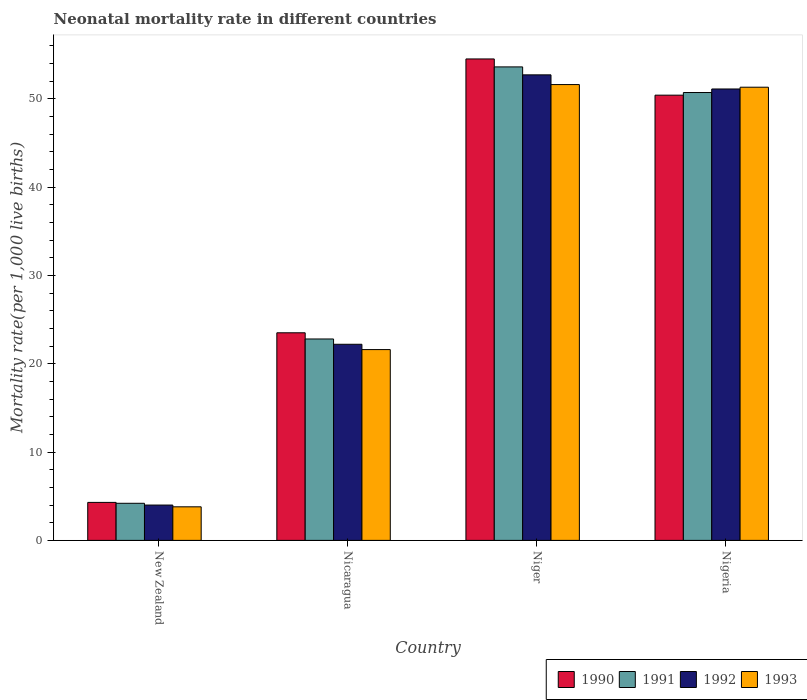How many groups of bars are there?
Make the answer very short. 4. How many bars are there on the 3rd tick from the right?
Offer a terse response. 4. What is the label of the 2nd group of bars from the left?
Provide a succinct answer. Nicaragua. What is the neonatal mortality rate in 1991 in New Zealand?
Offer a very short reply. 4.2. Across all countries, what is the maximum neonatal mortality rate in 1993?
Your answer should be compact. 51.6. Across all countries, what is the minimum neonatal mortality rate in 1993?
Your answer should be very brief. 3.8. In which country was the neonatal mortality rate in 1992 maximum?
Offer a very short reply. Niger. In which country was the neonatal mortality rate in 1990 minimum?
Give a very brief answer. New Zealand. What is the total neonatal mortality rate in 1992 in the graph?
Offer a very short reply. 130. What is the difference between the neonatal mortality rate in 1990 in Nicaragua and that in Niger?
Provide a short and direct response. -31. What is the difference between the neonatal mortality rate in 1990 in Niger and the neonatal mortality rate in 1992 in Nigeria?
Give a very brief answer. 3.4. What is the average neonatal mortality rate in 1991 per country?
Provide a short and direct response. 32.83. What is the difference between the neonatal mortality rate of/in 1992 and neonatal mortality rate of/in 1991 in New Zealand?
Give a very brief answer. -0.2. What is the ratio of the neonatal mortality rate in 1990 in New Zealand to that in Nicaragua?
Offer a terse response. 0.18. Is the neonatal mortality rate in 1991 in New Zealand less than that in Nigeria?
Make the answer very short. Yes. Is the difference between the neonatal mortality rate in 1992 in Nicaragua and Nigeria greater than the difference between the neonatal mortality rate in 1991 in Nicaragua and Nigeria?
Your answer should be very brief. No. What is the difference between the highest and the second highest neonatal mortality rate in 1992?
Ensure brevity in your answer.  -1.6. What is the difference between the highest and the lowest neonatal mortality rate in 1990?
Your response must be concise. 50.2. In how many countries, is the neonatal mortality rate in 1992 greater than the average neonatal mortality rate in 1992 taken over all countries?
Make the answer very short. 2. Is it the case that in every country, the sum of the neonatal mortality rate in 1991 and neonatal mortality rate in 1992 is greater than the sum of neonatal mortality rate in 1990 and neonatal mortality rate in 1993?
Give a very brief answer. No. What does the 4th bar from the right in Niger represents?
Give a very brief answer. 1990. Is it the case that in every country, the sum of the neonatal mortality rate in 1990 and neonatal mortality rate in 1991 is greater than the neonatal mortality rate in 1993?
Provide a short and direct response. Yes. How many bars are there?
Provide a succinct answer. 16. How many countries are there in the graph?
Offer a very short reply. 4. Are the values on the major ticks of Y-axis written in scientific E-notation?
Provide a short and direct response. No. Does the graph contain any zero values?
Keep it short and to the point. No. Does the graph contain grids?
Your answer should be compact. No. Where does the legend appear in the graph?
Keep it short and to the point. Bottom right. How are the legend labels stacked?
Provide a succinct answer. Horizontal. What is the title of the graph?
Offer a very short reply. Neonatal mortality rate in different countries. Does "2010" appear as one of the legend labels in the graph?
Your answer should be compact. No. What is the label or title of the X-axis?
Make the answer very short. Country. What is the label or title of the Y-axis?
Offer a very short reply. Mortality rate(per 1,0 live births). What is the Mortality rate(per 1,000 live births) of 1990 in New Zealand?
Give a very brief answer. 4.3. What is the Mortality rate(per 1,000 live births) in 1992 in New Zealand?
Your answer should be very brief. 4. What is the Mortality rate(per 1,000 live births) in 1991 in Nicaragua?
Give a very brief answer. 22.8. What is the Mortality rate(per 1,000 live births) of 1992 in Nicaragua?
Ensure brevity in your answer.  22.2. What is the Mortality rate(per 1,000 live births) of 1993 in Nicaragua?
Keep it short and to the point. 21.6. What is the Mortality rate(per 1,000 live births) of 1990 in Niger?
Offer a terse response. 54.5. What is the Mortality rate(per 1,000 live births) in 1991 in Niger?
Your answer should be very brief. 53.6. What is the Mortality rate(per 1,000 live births) in 1992 in Niger?
Give a very brief answer. 52.7. What is the Mortality rate(per 1,000 live births) of 1993 in Niger?
Your answer should be very brief. 51.6. What is the Mortality rate(per 1,000 live births) of 1990 in Nigeria?
Your response must be concise. 50.4. What is the Mortality rate(per 1,000 live births) of 1991 in Nigeria?
Provide a short and direct response. 50.7. What is the Mortality rate(per 1,000 live births) in 1992 in Nigeria?
Your response must be concise. 51.1. What is the Mortality rate(per 1,000 live births) in 1993 in Nigeria?
Make the answer very short. 51.3. Across all countries, what is the maximum Mortality rate(per 1,000 live births) of 1990?
Provide a succinct answer. 54.5. Across all countries, what is the maximum Mortality rate(per 1,000 live births) of 1991?
Your answer should be compact. 53.6. Across all countries, what is the maximum Mortality rate(per 1,000 live births) in 1992?
Offer a very short reply. 52.7. Across all countries, what is the maximum Mortality rate(per 1,000 live births) in 1993?
Ensure brevity in your answer.  51.6. Across all countries, what is the minimum Mortality rate(per 1,000 live births) of 1991?
Give a very brief answer. 4.2. Across all countries, what is the minimum Mortality rate(per 1,000 live births) of 1992?
Make the answer very short. 4. What is the total Mortality rate(per 1,000 live births) of 1990 in the graph?
Your answer should be compact. 132.7. What is the total Mortality rate(per 1,000 live births) in 1991 in the graph?
Your response must be concise. 131.3. What is the total Mortality rate(per 1,000 live births) of 1992 in the graph?
Keep it short and to the point. 130. What is the total Mortality rate(per 1,000 live births) in 1993 in the graph?
Ensure brevity in your answer.  128.3. What is the difference between the Mortality rate(per 1,000 live births) in 1990 in New Zealand and that in Nicaragua?
Keep it short and to the point. -19.2. What is the difference between the Mortality rate(per 1,000 live births) of 1991 in New Zealand and that in Nicaragua?
Your answer should be compact. -18.6. What is the difference between the Mortality rate(per 1,000 live births) of 1992 in New Zealand and that in Nicaragua?
Your answer should be compact. -18.2. What is the difference between the Mortality rate(per 1,000 live births) in 1993 in New Zealand and that in Nicaragua?
Give a very brief answer. -17.8. What is the difference between the Mortality rate(per 1,000 live births) of 1990 in New Zealand and that in Niger?
Ensure brevity in your answer.  -50.2. What is the difference between the Mortality rate(per 1,000 live births) in 1991 in New Zealand and that in Niger?
Offer a terse response. -49.4. What is the difference between the Mortality rate(per 1,000 live births) of 1992 in New Zealand and that in Niger?
Ensure brevity in your answer.  -48.7. What is the difference between the Mortality rate(per 1,000 live births) in 1993 in New Zealand and that in Niger?
Your answer should be very brief. -47.8. What is the difference between the Mortality rate(per 1,000 live births) of 1990 in New Zealand and that in Nigeria?
Keep it short and to the point. -46.1. What is the difference between the Mortality rate(per 1,000 live births) of 1991 in New Zealand and that in Nigeria?
Your answer should be compact. -46.5. What is the difference between the Mortality rate(per 1,000 live births) of 1992 in New Zealand and that in Nigeria?
Ensure brevity in your answer.  -47.1. What is the difference between the Mortality rate(per 1,000 live births) in 1993 in New Zealand and that in Nigeria?
Your answer should be very brief. -47.5. What is the difference between the Mortality rate(per 1,000 live births) of 1990 in Nicaragua and that in Niger?
Give a very brief answer. -31. What is the difference between the Mortality rate(per 1,000 live births) in 1991 in Nicaragua and that in Niger?
Provide a succinct answer. -30.8. What is the difference between the Mortality rate(per 1,000 live births) in 1992 in Nicaragua and that in Niger?
Provide a succinct answer. -30.5. What is the difference between the Mortality rate(per 1,000 live births) in 1993 in Nicaragua and that in Niger?
Make the answer very short. -30. What is the difference between the Mortality rate(per 1,000 live births) in 1990 in Nicaragua and that in Nigeria?
Keep it short and to the point. -26.9. What is the difference between the Mortality rate(per 1,000 live births) in 1991 in Nicaragua and that in Nigeria?
Give a very brief answer. -27.9. What is the difference between the Mortality rate(per 1,000 live births) in 1992 in Nicaragua and that in Nigeria?
Your answer should be compact. -28.9. What is the difference between the Mortality rate(per 1,000 live births) of 1993 in Nicaragua and that in Nigeria?
Offer a terse response. -29.7. What is the difference between the Mortality rate(per 1,000 live births) of 1992 in Niger and that in Nigeria?
Give a very brief answer. 1.6. What is the difference between the Mortality rate(per 1,000 live births) of 1990 in New Zealand and the Mortality rate(per 1,000 live births) of 1991 in Nicaragua?
Your answer should be compact. -18.5. What is the difference between the Mortality rate(per 1,000 live births) in 1990 in New Zealand and the Mortality rate(per 1,000 live births) in 1992 in Nicaragua?
Ensure brevity in your answer.  -17.9. What is the difference between the Mortality rate(per 1,000 live births) of 1990 in New Zealand and the Mortality rate(per 1,000 live births) of 1993 in Nicaragua?
Keep it short and to the point. -17.3. What is the difference between the Mortality rate(per 1,000 live births) in 1991 in New Zealand and the Mortality rate(per 1,000 live births) in 1992 in Nicaragua?
Provide a short and direct response. -18. What is the difference between the Mortality rate(per 1,000 live births) in 1991 in New Zealand and the Mortality rate(per 1,000 live births) in 1993 in Nicaragua?
Ensure brevity in your answer.  -17.4. What is the difference between the Mortality rate(per 1,000 live births) in 1992 in New Zealand and the Mortality rate(per 1,000 live births) in 1993 in Nicaragua?
Give a very brief answer. -17.6. What is the difference between the Mortality rate(per 1,000 live births) in 1990 in New Zealand and the Mortality rate(per 1,000 live births) in 1991 in Niger?
Provide a succinct answer. -49.3. What is the difference between the Mortality rate(per 1,000 live births) of 1990 in New Zealand and the Mortality rate(per 1,000 live births) of 1992 in Niger?
Your response must be concise. -48.4. What is the difference between the Mortality rate(per 1,000 live births) in 1990 in New Zealand and the Mortality rate(per 1,000 live births) in 1993 in Niger?
Your answer should be very brief. -47.3. What is the difference between the Mortality rate(per 1,000 live births) in 1991 in New Zealand and the Mortality rate(per 1,000 live births) in 1992 in Niger?
Keep it short and to the point. -48.5. What is the difference between the Mortality rate(per 1,000 live births) in 1991 in New Zealand and the Mortality rate(per 1,000 live births) in 1993 in Niger?
Offer a terse response. -47.4. What is the difference between the Mortality rate(per 1,000 live births) of 1992 in New Zealand and the Mortality rate(per 1,000 live births) of 1993 in Niger?
Offer a terse response. -47.6. What is the difference between the Mortality rate(per 1,000 live births) of 1990 in New Zealand and the Mortality rate(per 1,000 live births) of 1991 in Nigeria?
Keep it short and to the point. -46.4. What is the difference between the Mortality rate(per 1,000 live births) in 1990 in New Zealand and the Mortality rate(per 1,000 live births) in 1992 in Nigeria?
Your response must be concise. -46.8. What is the difference between the Mortality rate(per 1,000 live births) of 1990 in New Zealand and the Mortality rate(per 1,000 live births) of 1993 in Nigeria?
Keep it short and to the point. -47. What is the difference between the Mortality rate(per 1,000 live births) of 1991 in New Zealand and the Mortality rate(per 1,000 live births) of 1992 in Nigeria?
Your response must be concise. -46.9. What is the difference between the Mortality rate(per 1,000 live births) of 1991 in New Zealand and the Mortality rate(per 1,000 live births) of 1993 in Nigeria?
Offer a terse response. -47.1. What is the difference between the Mortality rate(per 1,000 live births) of 1992 in New Zealand and the Mortality rate(per 1,000 live births) of 1993 in Nigeria?
Ensure brevity in your answer.  -47.3. What is the difference between the Mortality rate(per 1,000 live births) of 1990 in Nicaragua and the Mortality rate(per 1,000 live births) of 1991 in Niger?
Your answer should be compact. -30.1. What is the difference between the Mortality rate(per 1,000 live births) of 1990 in Nicaragua and the Mortality rate(per 1,000 live births) of 1992 in Niger?
Offer a very short reply. -29.2. What is the difference between the Mortality rate(per 1,000 live births) in 1990 in Nicaragua and the Mortality rate(per 1,000 live births) in 1993 in Niger?
Provide a short and direct response. -28.1. What is the difference between the Mortality rate(per 1,000 live births) of 1991 in Nicaragua and the Mortality rate(per 1,000 live births) of 1992 in Niger?
Keep it short and to the point. -29.9. What is the difference between the Mortality rate(per 1,000 live births) of 1991 in Nicaragua and the Mortality rate(per 1,000 live births) of 1993 in Niger?
Your answer should be compact. -28.8. What is the difference between the Mortality rate(per 1,000 live births) of 1992 in Nicaragua and the Mortality rate(per 1,000 live births) of 1993 in Niger?
Your response must be concise. -29.4. What is the difference between the Mortality rate(per 1,000 live births) in 1990 in Nicaragua and the Mortality rate(per 1,000 live births) in 1991 in Nigeria?
Ensure brevity in your answer.  -27.2. What is the difference between the Mortality rate(per 1,000 live births) in 1990 in Nicaragua and the Mortality rate(per 1,000 live births) in 1992 in Nigeria?
Provide a succinct answer. -27.6. What is the difference between the Mortality rate(per 1,000 live births) of 1990 in Nicaragua and the Mortality rate(per 1,000 live births) of 1993 in Nigeria?
Your answer should be very brief. -27.8. What is the difference between the Mortality rate(per 1,000 live births) of 1991 in Nicaragua and the Mortality rate(per 1,000 live births) of 1992 in Nigeria?
Provide a succinct answer. -28.3. What is the difference between the Mortality rate(per 1,000 live births) in 1991 in Nicaragua and the Mortality rate(per 1,000 live births) in 1993 in Nigeria?
Your response must be concise. -28.5. What is the difference between the Mortality rate(per 1,000 live births) of 1992 in Nicaragua and the Mortality rate(per 1,000 live births) of 1993 in Nigeria?
Your answer should be compact. -29.1. What is the difference between the Mortality rate(per 1,000 live births) in 1990 in Niger and the Mortality rate(per 1,000 live births) in 1991 in Nigeria?
Provide a succinct answer. 3.8. What is the difference between the Mortality rate(per 1,000 live births) in 1990 in Niger and the Mortality rate(per 1,000 live births) in 1992 in Nigeria?
Your answer should be compact. 3.4. What is the difference between the Mortality rate(per 1,000 live births) in 1991 in Niger and the Mortality rate(per 1,000 live births) in 1992 in Nigeria?
Make the answer very short. 2.5. What is the difference between the Mortality rate(per 1,000 live births) of 1991 in Niger and the Mortality rate(per 1,000 live births) of 1993 in Nigeria?
Offer a very short reply. 2.3. What is the average Mortality rate(per 1,000 live births) of 1990 per country?
Keep it short and to the point. 33.17. What is the average Mortality rate(per 1,000 live births) in 1991 per country?
Offer a very short reply. 32.83. What is the average Mortality rate(per 1,000 live births) of 1992 per country?
Your answer should be very brief. 32.5. What is the average Mortality rate(per 1,000 live births) in 1993 per country?
Your response must be concise. 32.08. What is the difference between the Mortality rate(per 1,000 live births) in 1990 and Mortality rate(per 1,000 live births) in 1991 in New Zealand?
Provide a short and direct response. 0.1. What is the difference between the Mortality rate(per 1,000 live births) of 1990 and Mortality rate(per 1,000 live births) of 1993 in New Zealand?
Your answer should be compact. 0.5. What is the difference between the Mortality rate(per 1,000 live births) of 1991 and Mortality rate(per 1,000 live births) of 1992 in New Zealand?
Give a very brief answer. 0.2. What is the difference between the Mortality rate(per 1,000 live births) in 1991 and Mortality rate(per 1,000 live births) in 1993 in New Zealand?
Provide a succinct answer. 0.4. What is the difference between the Mortality rate(per 1,000 live births) of 1992 and Mortality rate(per 1,000 live births) of 1993 in New Zealand?
Make the answer very short. 0.2. What is the difference between the Mortality rate(per 1,000 live births) of 1991 and Mortality rate(per 1,000 live births) of 1992 in Nicaragua?
Your answer should be very brief. 0.6. What is the difference between the Mortality rate(per 1,000 live births) in 1991 and Mortality rate(per 1,000 live births) in 1993 in Nicaragua?
Keep it short and to the point. 1.2. What is the difference between the Mortality rate(per 1,000 live births) of 1990 and Mortality rate(per 1,000 live births) of 1992 in Niger?
Give a very brief answer. 1.8. What is the difference between the Mortality rate(per 1,000 live births) in 1990 and Mortality rate(per 1,000 live births) in 1993 in Niger?
Ensure brevity in your answer.  2.9. What is the difference between the Mortality rate(per 1,000 live births) of 1991 and Mortality rate(per 1,000 live births) of 1992 in Niger?
Make the answer very short. 0.9. What is the difference between the Mortality rate(per 1,000 live births) in 1991 and Mortality rate(per 1,000 live births) in 1993 in Niger?
Offer a very short reply. 2. What is the difference between the Mortality rate(per 1,000 live births) of 1990 and Mortality rate(per 1,000 live births) of 1993 in Nigeria?
Provide a succinct answer. -0.9. What is the ratio of the Mortality rate(per 1,000 live births) of 1990 in New Zealand to that in Nicaragua?
Your response must be concise. 0.18. What is the ratio of the Mortality rate(per 1,000 live births) in 1991 in New Zealand to that in Nicaragua?
Keep it short and to the point. 0.18. What is the ratio of the Mortality rate(per 1,000 live births) of 1992 in New Zealand to that in Nicaragua?
Your answer should be very brief. 0.18. What is the ratio of the Mortality rate(per 1,000 live births) in 1993 in New Zealand to that in Nicaragua?
Give a very brief answer. 0.18. What is the ratio of the Mortality rate(per 1,000 live births) in 1990 in New Zealand to that in Niger?
Make the answer very short. 0.08. What is the ratio of the Mortality rate(per 1,000 live births) in 1991 in New Zealand to that in Niger?
Offer a very short reply. 0.08. What is the ratio of the Mortality rate(per 1,000 live births) of 1992 in New Zealand to that in Niger?
Your answer should be compact. 0.08. What is the ratio of the Mortality rate(per 1,000 live births) of 1993 in New Zealand to that in Niger?
Give a very brief answer. 0.07. What is the ratio of the Mortality rate(per 1,000 live births) in 1990 in New Zealand to that in Nigeria?
Ensure brevity in your answer.  0.09. What is the ratio of the Mortality rate(per 1,000 live births) in 1991 in New Zealand to that in Nigeria?
Your answer should be very brief. 0.08. What is the ratio of the Mortality rate(per 1,000 live births) in 1992 in New Zealand to that in Nigeria?
Provide a succinct answer. 0.08. What is the ratio of the Mortality rate(per 1,000 live births) of 1993 in New Zealand to that in Nigeria?
Offer a very short reply. 0.07. What is the ratio of the Mortality rate(per 1,000 live births) in 1990 in Nicaragua to that in Niger?
Your response must be concise. 0.43. What is the ratio of the Mortality rate(per 1,000 live births) in 1991 in Nicaragua to that in Niger?
Offer a terse response. 0.43. What is the ratio of the Mortality rate(per 1,000 live births) of 1992 in Nicaragua to that in Niger?
Your response must be concise. 0.42. What is the ratio of the Mortality rate(per 1,000 live births) of 1993 in Nicaragua to that in Niger?
Provide a succinct answer. 0.42. What is the ratio of the Mortality rate(per 1,000 live births) in 1990 in Nicaragua to that in Nigeria?
Provide a succinct answer. 0.47. What is the ratio of the Mortality rate(per 1,000 live births) in 1991 in Nicaragua to that in Nigeria?
Your answer should be very brief. 0.45. What is the ratio of the Mortality rate(per 1,000 live births) of 1992 in Nicaragua to that in Nigeria?
Provide a short and direct response. 0.43. What is the ratio of the Mortality rate(per 1,000 live births) in 1993 in Nicaragua to that in Nigeria?
Your answer should be compact. 0.42. What is the ratio of the Mortality rate(per 1,000 live births) in 1990 in Niger to that in Nigeria?
Offer a very short reply. 1.08. What is the ratio of the Mortality rate(per 1,000 live births) in 1991 in Niger to that in Nigeria?
Offer a terse response. 1.06. What is the ratio of the Mortality rate(per 1,000 live births) in 1992 in Niger to that in Nigeria?
Give a very brief answer. 1.03. What is the difference between the highest and the second highest Mortality rate(per 1,000 live births) in 1990?
Make the answer very short. 4.1. What is the difference between the highest and the second highest Mortality rate(per 1,000 live births) in 1992?
Provide a short and direct response. 1.6. What is the difference between the highest and the second highest Mortality rate(per 1,000 live births) of 1993?
Your response must be concise. 0.3. What is the difference between the highest and the lowest Mortality rate(per 1,000 live births) of 1990?
Give a very brief answer. 50.2. What is the difference between the highest and the lowest Mortality rate(per 1,000 live births) of 1991?
Offer a very short reply. 49.4. What is the difference between the highest and the lowest Mortality rate(per 1,000 live births) in 1992?
Provide a short and direct response. 48.7. What is the difference between the highest and the lowest Mortality rate(per 1,000 live births) of 1993?
Your answer should be very brief. 47.8. 